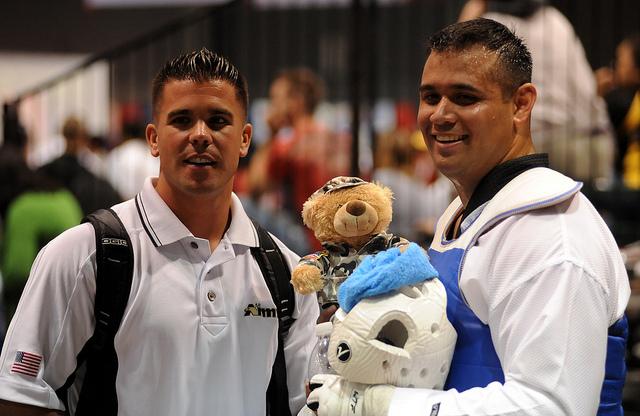Why is the man wearing protection?
Answer briefly. For safety. What kind of toy is the man holding?
Write a very short answer. Teddy bear. Are the men happy?
Be succinct. Yes. 